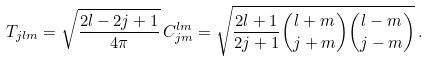Convert formula to latex. <formula><loc_0><loc_0><loc_500><loc_500>T _ { j l m } = \sqrt { \frac { 2 l - 2 j + 1 } { 4 \pi } } \, C _ { j m } ^ { l m } = \sqrt { \frac { 2 l + 1 } { 2 j + 1 } \binom { l + m } { j + m } \binom { l - m } { j - m } } \, .</formula> 